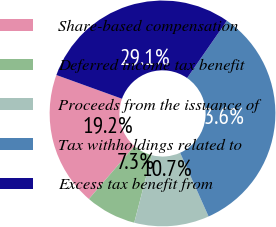<chart> <loc_0><loc_0><loc_500><loc_500><pie_chart><fcel>Share-based compensation<fcel>Deferred income tax benefit<fcel>Proceeds from the issuance of<fcel>Tax withholdings related to<fcel>Excess tax benefit from<nl><fcel>19.22%<fcel>7.28%<fcel>10.72%<fcel>33.65%<fcel>29.14%<nl></chart> 